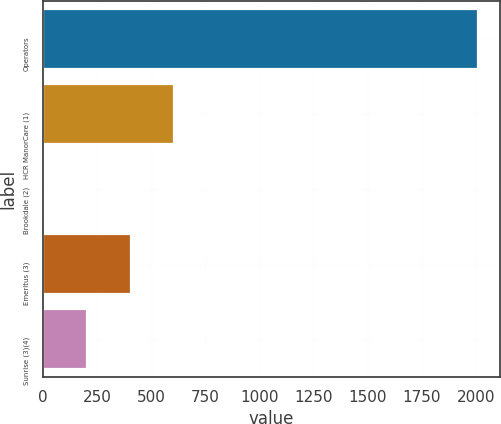<chart> <loc_0><loc_0><loc_500><loc_500><bar_chart><fcel>Operators<fcel>HCR ManorCare (1)<fcel>Brookdale (2)<fcel>Emeritus (3)<fcel>Sunrise (3)(4)<nl><fcel>2012<fcel>607.1<fcel>5<fcel>406.4<fcel>205.7<nl></chart> 